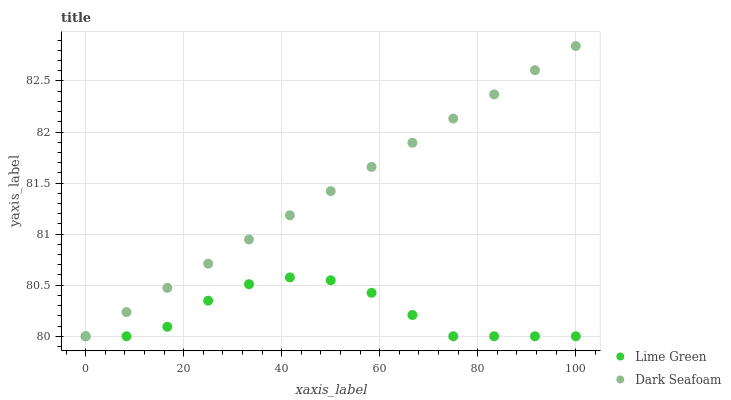Does Lime Green have the minimum area under the curve?
Answer yes or no. Yes. Does Dark Seafoam have the maximum area under the curve?
Answer yes or no. Yes. Does Lime Green have the maximum area under the curve?
Answer yes or no. No. Is Dark Seafoam the smoothest?
Answer yes or no. Yes. Is Lime Green the roughest?
Answer yes or no. Yes. Is Lime Green the smoothest?
Answer yes or no. No. Does Dark Seafoam have the lowest value?
Answer yes or no. Yes. Does Dark Seafoam have the highest value?
Answer yes or no. Yes. Does Lime Green have the highest value?
Answer yes or no. No. Does Lime Green intersect Dark Seafoam?
Answer yes or no. Yes. Is Lime Green less than Dark Seafoam?
Answer yes or no. No. Is Lime Green greater than Dark Seafoam?
Answer yes or no. No. 